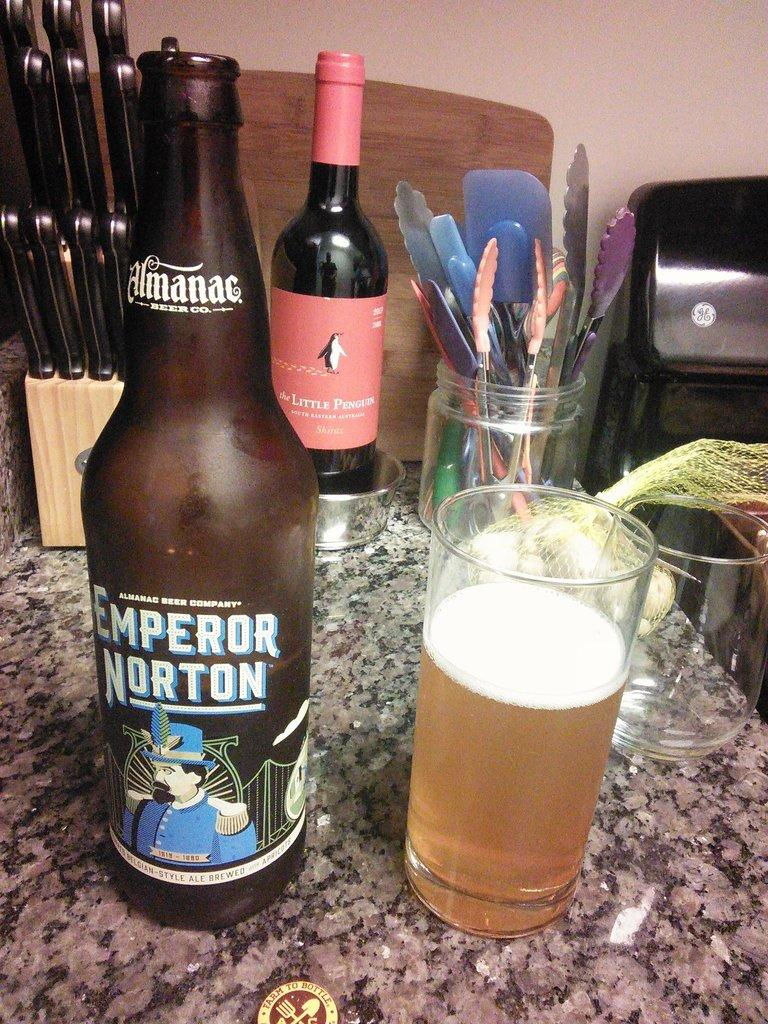<image>
Describe the image concisely. a bottle of emporer Norton on a table full of stuff 